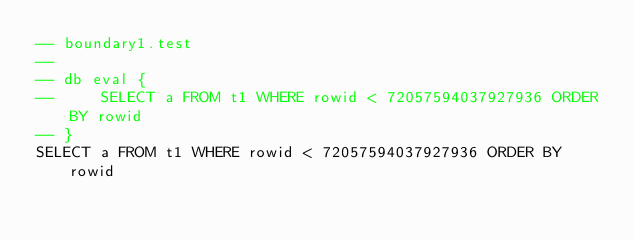<code> <loc_0><loc_0><loc_500><loc_500><_SQL_>-- boundary1.test
-- 
-- db eval {
--     SELECT a FROM t1 WHERE rowid < 72057594037927936 ORDER BY rowid
-- }
SELECT a FROM t1 WHERE rowid < 72057594037927936 ORDER BY rowid</code> 